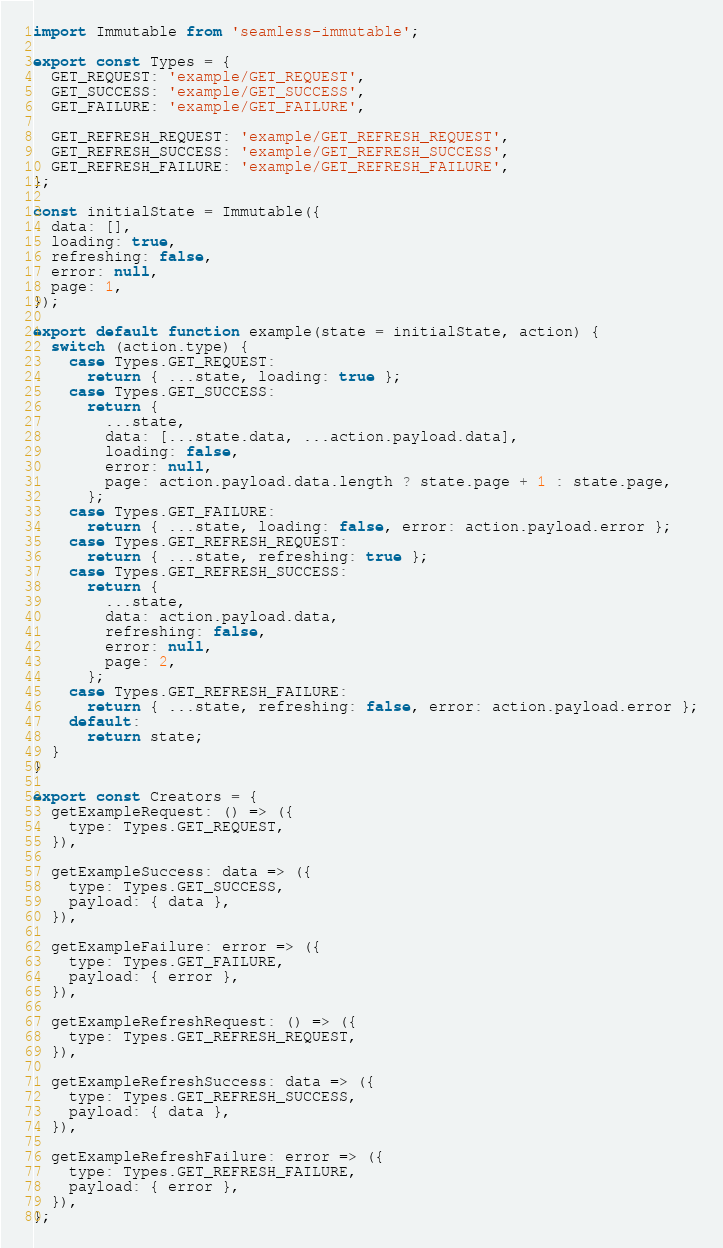Convert code to text. <code><loc_0><loc_0><loc_500><loc_500><_JavaScript_>import Immutable from 'seamless-immutable';

export const Types = {
  GET_REQUEST: 'example/GET_REQUEST',
  GET_SUCCESS: 'example/GET_SUCCESS',
  GET_FAILURE: 'example/GET_FAILURE',

  GET_REFRESH_REQUEST: 'example/GET_REFRESH_REQUEST',
  GET_REFRESH_SUCCESS: 'example/GET_REFRESH_SUCCESS',
  GET_REFRESH_FAILURE: 'example/GET_REFRESH_FAILURE',
};

const initialState = Immutable({
  data: [],
  loading: true,
  refreshing: false,
  error: null,
  page: 1,
});

export default function example(state = initialState, action) {
  switch (action.type) {
    case Types.GET_REQUEST:
      return { ...state, loading: true };
    case Types.GET_SUCCESS:
      return {
        ...state,
        data: [...state.data, ...action.payload.data],
        loading: false,
        error: null,
        page: action.payload.data.length ? state.page + 1 : state.page,
      };
    case Types.GET_FAILURE:
      return { ...state, loading: false, error: action.payload.error };
    case Types.GET_REFRESH_REQUEST:
      return { ...state, refreshing: true };
    case Types.GET_REFRESH_SUCCESS:
      return {
        ...state,
        data: action.payload.data,
        refreshing: false,
        error: null,
        page: 2,
      };
    case Types.GET_REFRESH_FAILURE:
      return { ...state, refreshing: false, error: action.payload.error };
    default:
      return state;
  }
}

export const Creators = {
  getExampleRequest: () => ({
    type: Types.GET_REQUEST,
  }),

  getExampleSuccess: data => ({
    type: Types.GET_SUCCESS,
    payload: { data },
  }),

  getExampleFailure: error => ({
    type: Types.GET_FAILURE,
    payload: { error },
  }),

  getExampleRefreshRequest: () => ({
    type: Types.GET_REFRESH_REQUEST,
  }),

  getExampleRefreshSuccess: data => ({
    type: Types.GET_REFRESH_SUCCESS,
    payload: { data },
  }),

  getExampleRefreshFailure: error => ({
    type: Types.GET_REFRESH_FAILURE,
    payload: { error },
  }),
};
</code> 